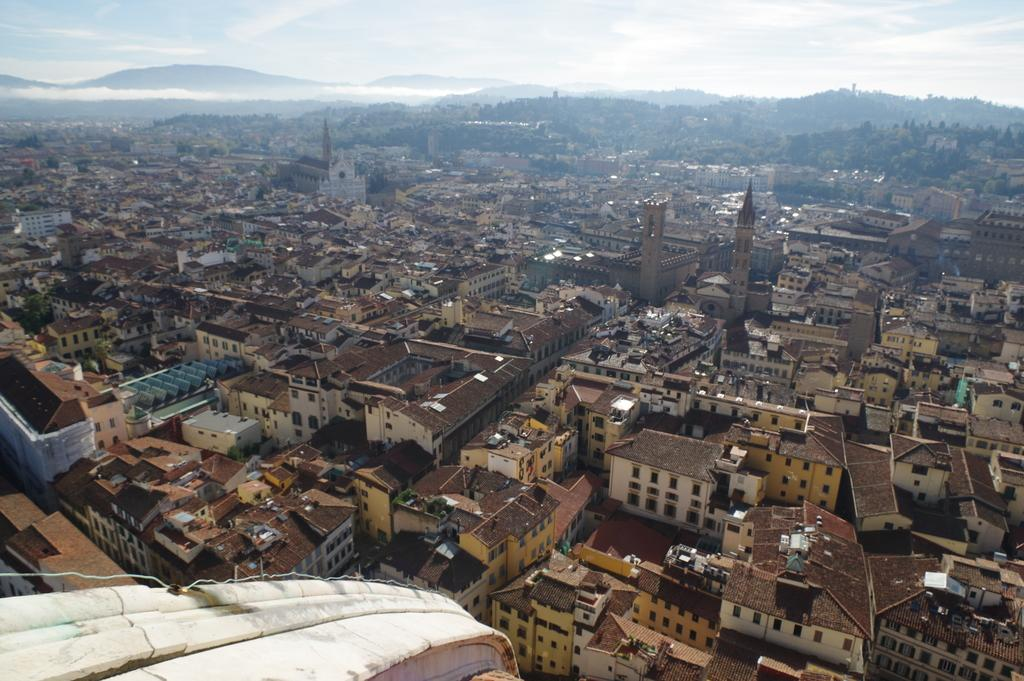What type of structures can be seen in the image? There are buildings in the image. What can be seen in the background of the image? There are trees, mountains, and the sky visible in the background of the image. What story is being told by the zephyr in the image? There is no zephyr present in the image, and therefore no story can be told by it. 